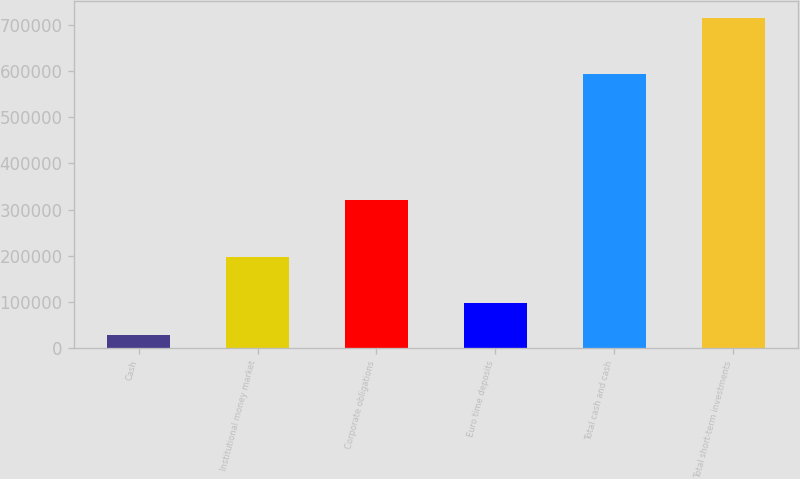Convert chart to OTSL. <chart><loc_0><loc_0><loc_500><loc_500><bar_chart><fcel>Cash<fcel>Institutional money market<fcel>Corporate obligations<fcel>Euro time deposits<fcel>Total cash and cash<fcel>Total short-term investments<nl><fcel>27910<fcel>197735<fcel>321200<fcel>96727.7<fcel>593599<fcel>716087<nl></chart> 